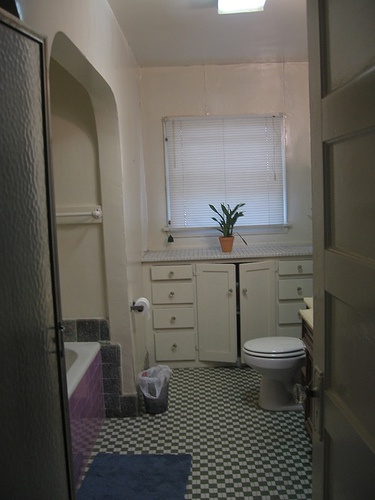Describe the objects in this image and their specific colors. I can see toilet in black and gray tones and potted plant in black, gray, darkgray, and brown tones in this image. 